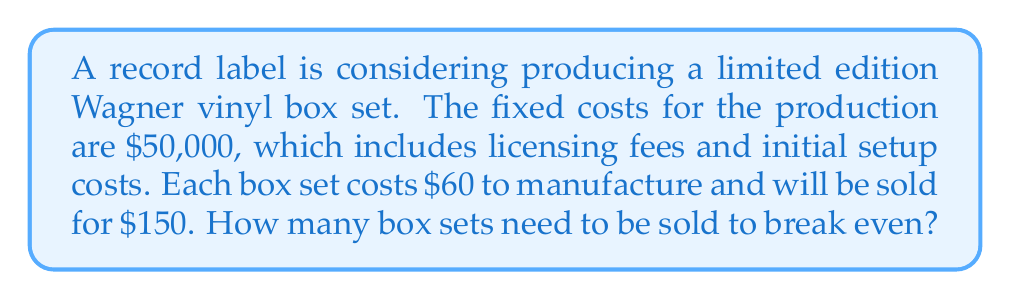Can you solve this math problem? To solve this problem, we need to use the break-even analysis formula. The break-even point is where total revenue equals total costs.

Let's define our variables:
$x$ = number of box sets sold
$F$ = fixed costs
$P$ = price per box set
$V$ = variable cost per box set

We know:
$F = \$50,000$
$P = \$150$
$V = \$60$

The break-even formula is:

$$ Fx + Px = Vx + F $$

Where $Fx + Px$ represents total revenue, and $Vx + F$ represents total costs.

Substituting our values:

$$ 50,000 + 150x = 60x + 50,000 $$

Simplifying:

$$ 150x = 60x + 50,000 $$
$$ 90x = 50,000 $$

Solving for $x$:

$$ x = \frac{50,000}{90} = 555.56 $$

Since we can't sell a fraction of a box set, we round up to the nearest whole number.
Answer: The label needs to sell 556 box sets to break even. 